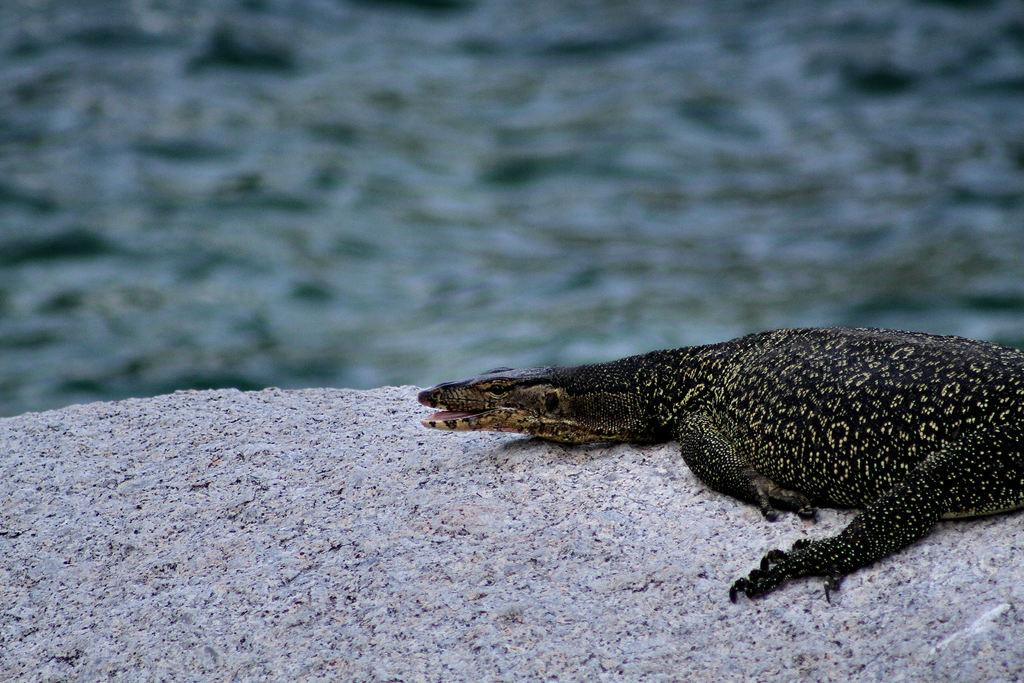What type of animal is in the image? There is a lizard in the image. Where is the lizard located? The lizard is on a rock. Can you describe the background of the image? The background of the image is blurred. What type of alarm is attached to the lizard in the image? There is: There is no alarm present in the image; it features a lizard on a rock with a blurred background. 